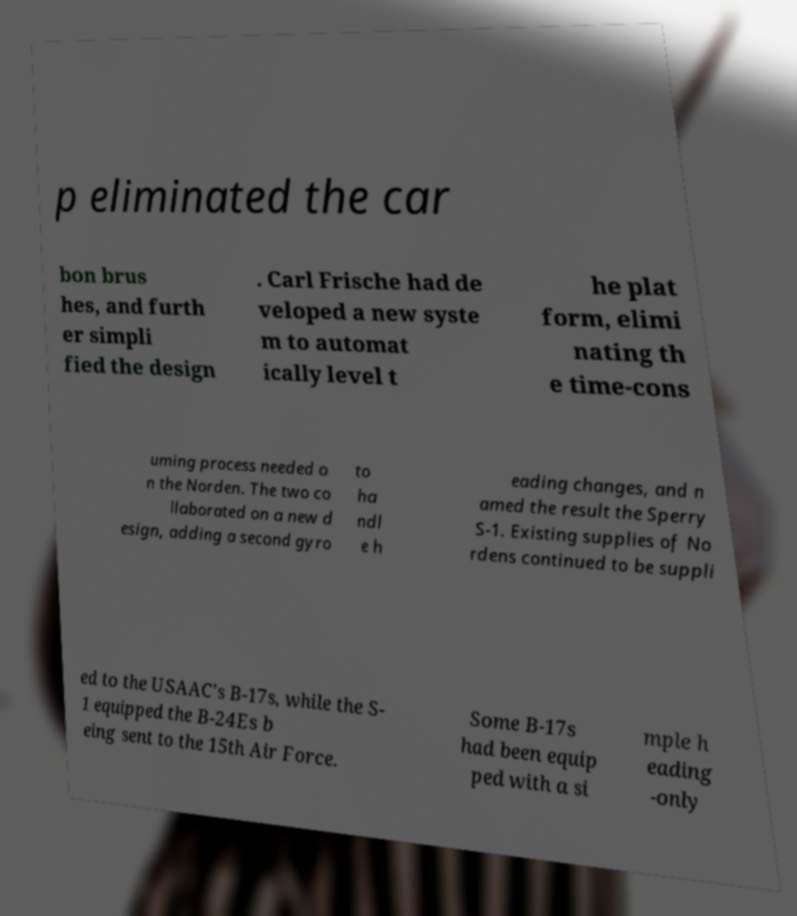Could you extract and type out the text from this image? p eliminated the car bon brus hes, and furth er simpli fied the design . Carl Frische had de veloped a new syste m to automat ically level t he plat form, elimi nating th e time-cons uming process needed o n the Norden. The two co llaborated on a new d esign, adding a second gyro to ha ndl e h eading changes, and n amed the result the Sperry S-1. Existing supplies of No rdens continued to be suppli ed to the USAAC's B-17s, while the S- 1 equipped the B-24Es b eing sent to the 15th Air Force. Some B-17s had been equip ped with a si mple h eading -only 